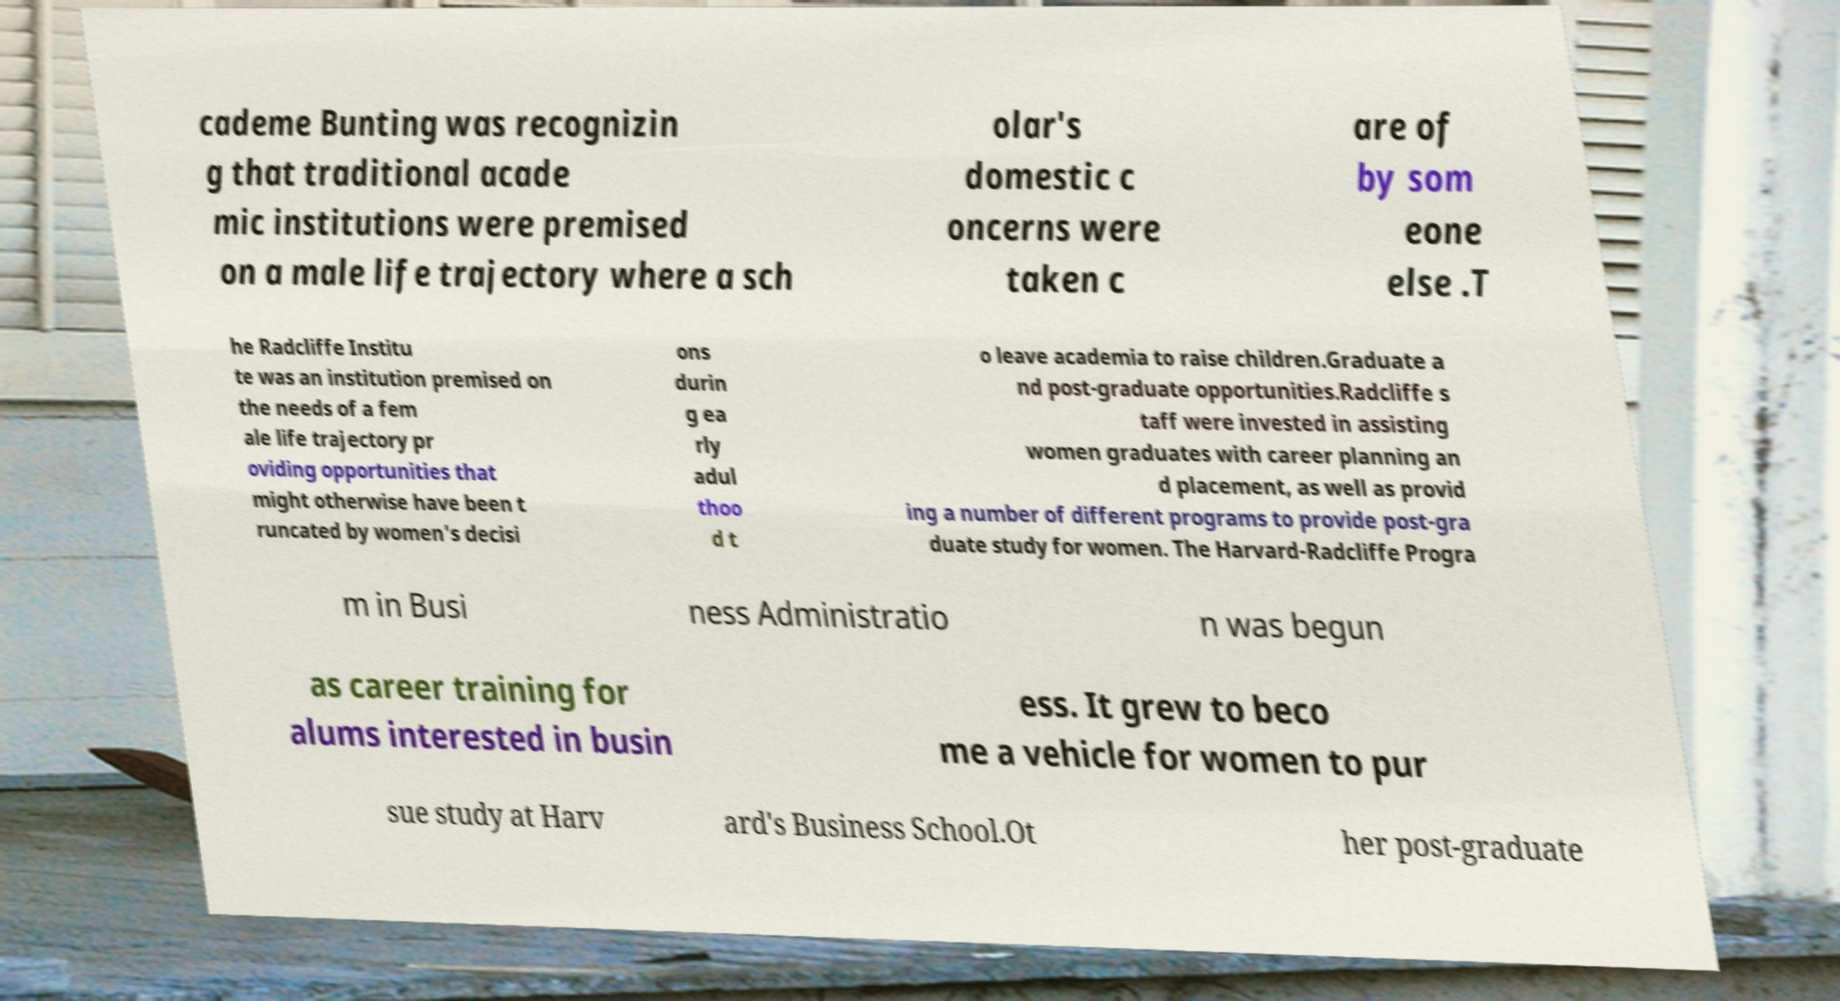There's text embedded in this image that I need extracted. Can you transcribe it verbatim? cademe Bunting was recognizin g that traditional acade mic institutions were premised on a male life trajectory where a sch olar's domestic c oncerns were taken c are of by som eone else .T he Radcliffe Institu te was an institution premised on the needs of a fem ale life trajectory pr oviding opportunities that might otherwise have been t runcated by women's decisi ons durin g ea rly adul thoo d t o leave academia to raise children.Graduate a nd post-graduate opportunities.Radcliffe s taff were invested in assisting women graduates with career planning an d placement, as well as provid ing a number of different programs to provide post-gra duate study for women. The Harvard-Radcliffe Progra m in Busi ness Administratio n was begun as career training for alums interested in busin ess. It grew to beco me a vehicle for women to pur sue study at Harv ard's Business School.Ot her post-graduate 